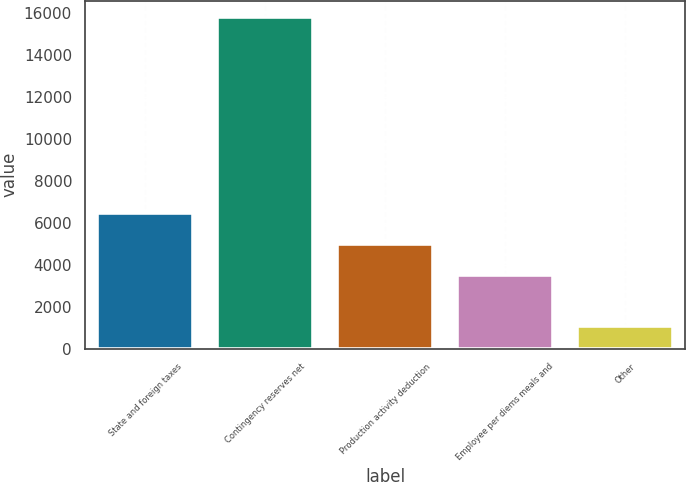<chart> <loc_0><loc_0><loc_500><loc_500><bar_chart><fcel>State and foreign taxes<fcel>Contingency reserves net<fcel>Production activity deduction<fcel>Employee per diems meals and<fcel>Other<nl><fcel>6479<fcel>15810<fcel>5008<fcel>3537<fcel>1100<nl></chart> 